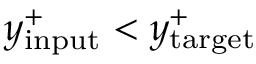<formula> <loc_0><loc_0><loc_500><loc_500>y _ { i n p u t } ^ { + } < y _ { t \arg e t } ^ { + }</formula> 